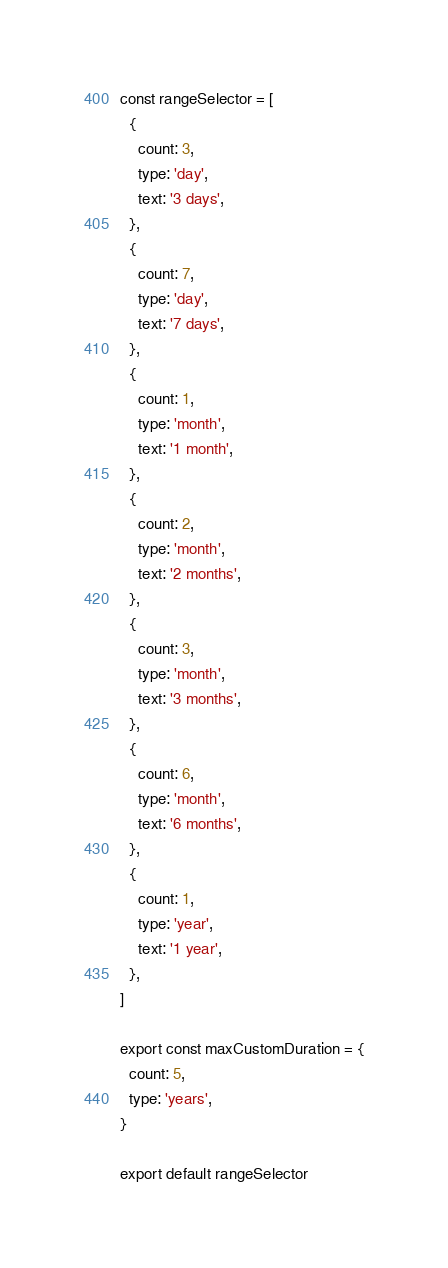Convert code to text. <code><loc_0><loc_0><loc_500><loc_500><_JavaScript_>const rangeSelector = [
  {
    count: 3,
    type: 'day',
    text: '3 days',
  },
  {
    count: 7,
    type: 'day',
    text: '7 days',
  },
  {
    count: 1,
    type: 'month',
    text: '1 month',
  },
  {
    count: 2,
    type: 'month',
    text: '2 months',
  },
  {
    count: 3,
    type: 'month',
    text: '3 months',
  },
  {
    count: 6,
    type: 'month',
    text: '6 months',
  },
  {
    count: 1,
    type: 'year',
    text: '1 year',
  },
]

export const maxCustomDuration = {
  count: 5,
  type: 'years',
}

export default rangeSelector
</code> 